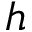<formula> <loc_0><loc_0><loc_500><loc_500>h</formula> 